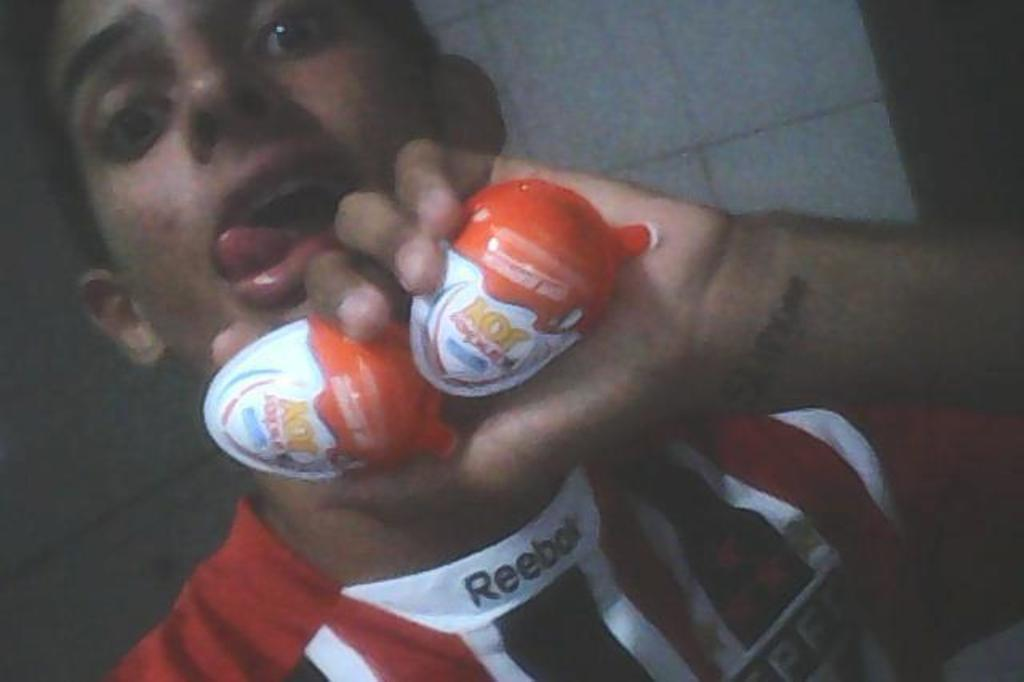Where was the image taken? The image was taken inside a room. Who is present in the image? There is a man in the image. What is the man holding in his hand? The man is holding a Kinder Joy in his hand. What color is the wall in the background of the image? The wall in the background of the image is white. Are there any veils visible in the image? No, there are no veils present in the image. What type of card can be seen on the table in the image? There is no card visible in the image; only a man holding a Kinder Joy and a white wall in the background are present. 